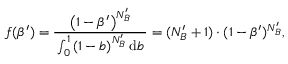<formula> <loc_0><loc_0><loc_500><loc_500>\, f ( \beta ^ { \prime } ) = \frac { \left ( 1 - \beta ^ { \prime } \right ) ^ { N _ { B } ^ { \prime } } } { \, \int _ { 0 } ^ { 1 } \left ( 1 - b \right ) ^ { N _ { B } ^ { \prime } } d b \, } = ( N _ { B } ^ { \prime } + 1 ) \cdot ( 1 - \beta ^ { \prime } ) ^ { N _ { B } ^ { \prime } } ,</formula> 